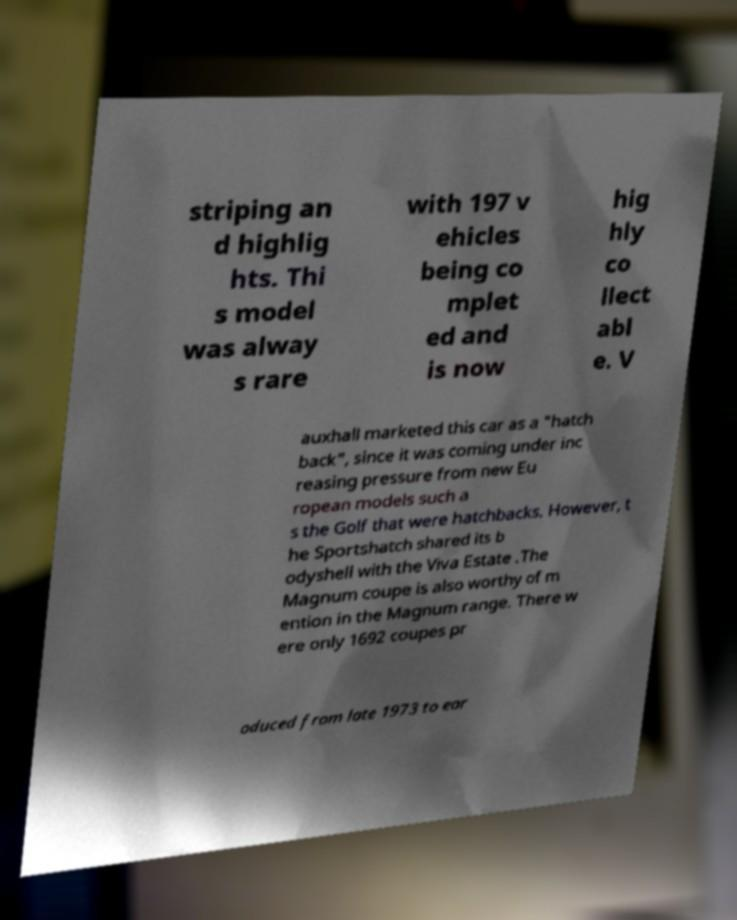Can you read and provide the text displayed in the image?This photo seems to have some interesting text. Can you extract and type it out for me? striping an d highlig hts. Thi s model was alway s rare with 197 v ehicles being co mplet ed and is now hig hly co llect abl e. V auxhall marketed this car as a "hatch back", since it was coming under inc reasing pressure from new Eu ropean models such a s the Golf that were hatchbacks. However, t he Sportshatch shared its b odyshell with the Viva Estate .The Magnum coupe is also worthy of m ention in the Magnum range. There w ere only 1692 coupes pr oduced from late 1973 to ear 